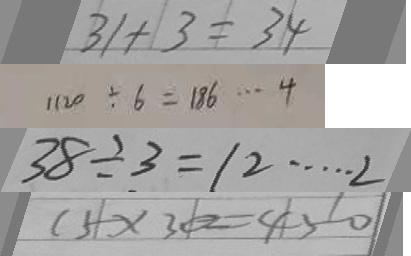Convert formula to latex. <formula><loc_0><loc_0><loc_500><loc_500>3 1 + 3 = 3 4 
 1 1 2 0 \div 6 = 1 8 6 \cdots 4 
 3 8 \div 3 = 1 2 \cdots 2 
 1 5 \times 3 0 = 4 5 0</formula> 